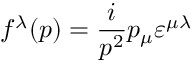<formula> <loc_0><loc_0><loc_500><loc_500>f ^ { \lambda } ( p ) = \frac { i } { p ^ { 2 } } p _ { \mu } \varepsilon ^ { \mu \lambda }</formula> 